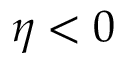Convert formula to latex. <formula><loc_0><loc_0><loc_500><loc_500>\eta < 0</formula> 